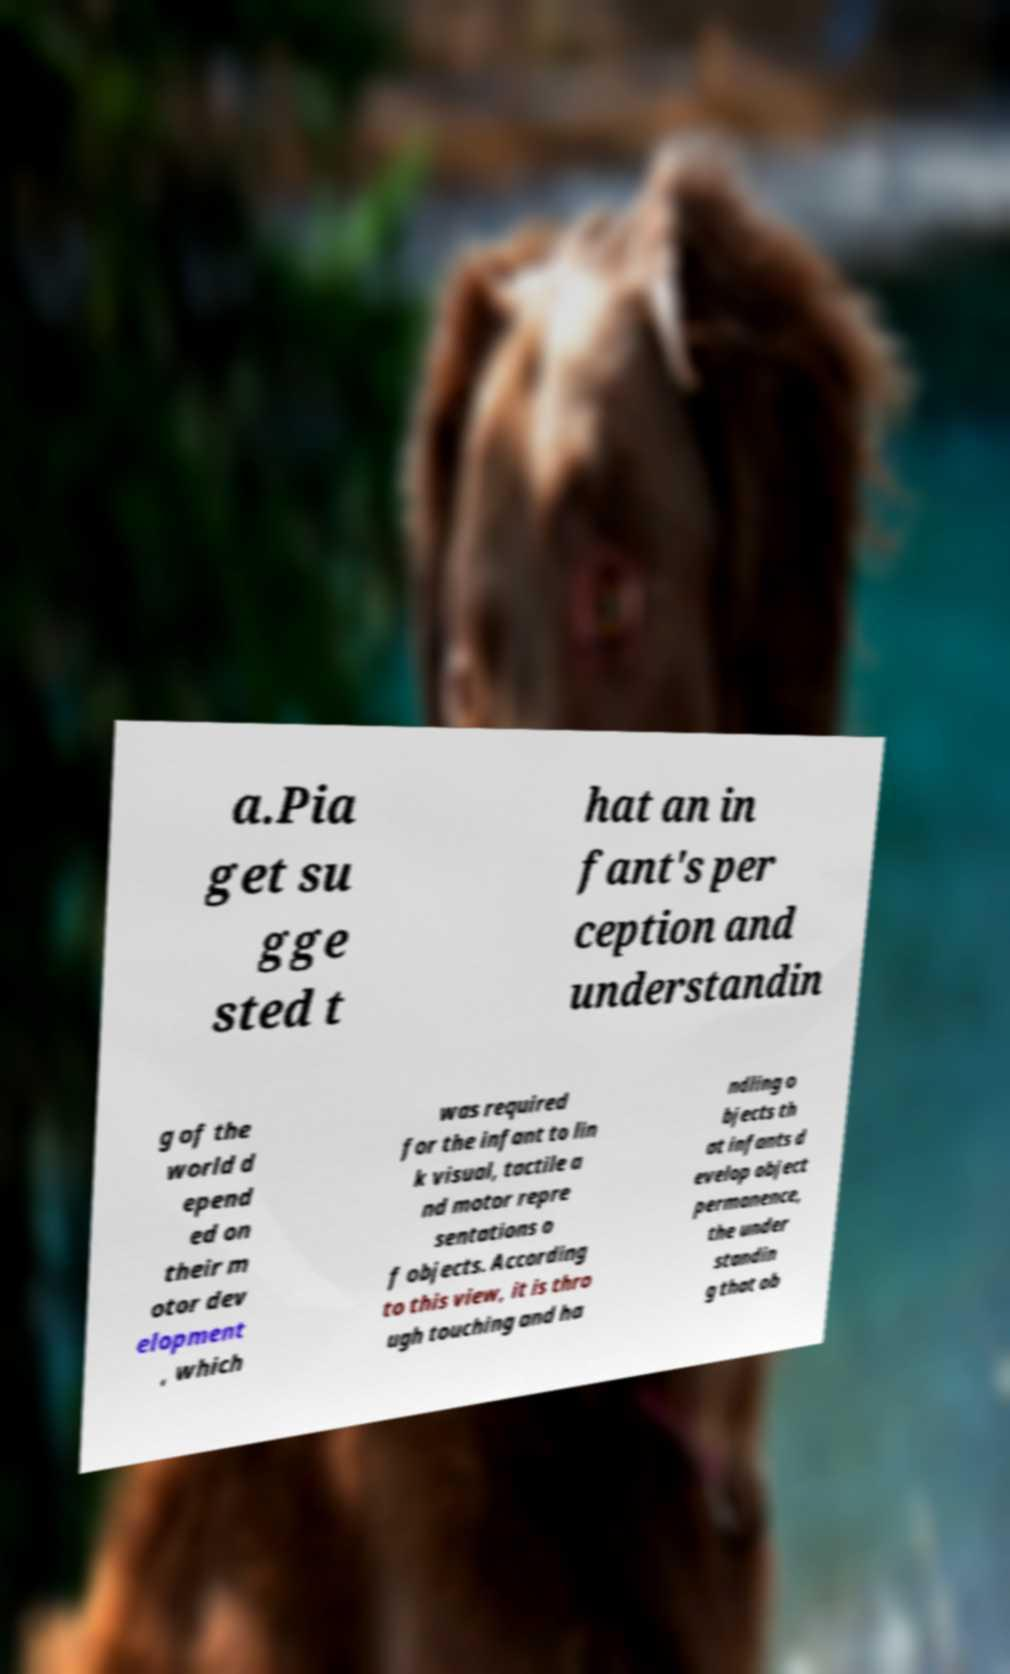What messages or text are displayed in this image? I need them in a readable, typed format. a.Pia get su gge sted t hat an in fant's per ception and understandin g of the world d epend ed on their m otor dev elopment , which was required for the infant to lin k visual, tactile a nd motor repre sentations o f objects. According to this view, it is thro ugh touching and ha ndling o bjects th at infants d evelop object permanence, the under standin g that ob 